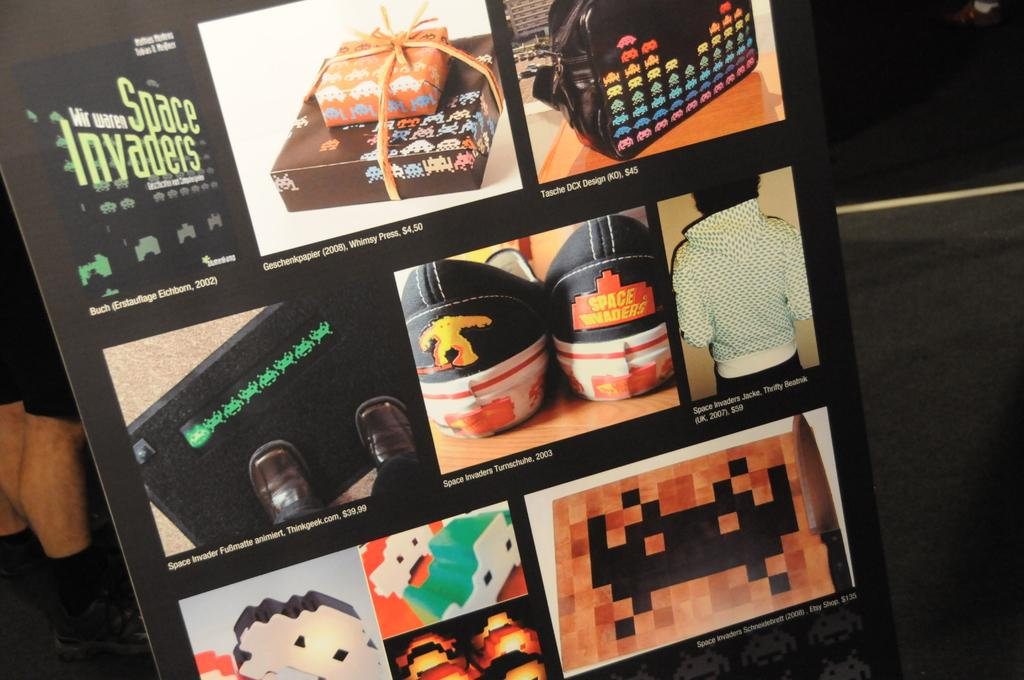What can be found in the image that contains written information? There is text in the image. What items in the image might be given as presents? There are gift boxes in the image. What type of container is visible in the image? There is a bag in the image. What type of clothing is visible in the image? There is footwear in the image. Who is present in the image? There is a person in the image. What other objects can be seen in the image besides the ones mentioned? There are other objects in the image. Where are the legs of the person located in the image? The legs of the person are visible on the left side of the image. What type of garden can be seen in the image? There is no garden present in the image. What committee is responsible for organizing the event in the image? There is no committee or event mentioned in the image. 